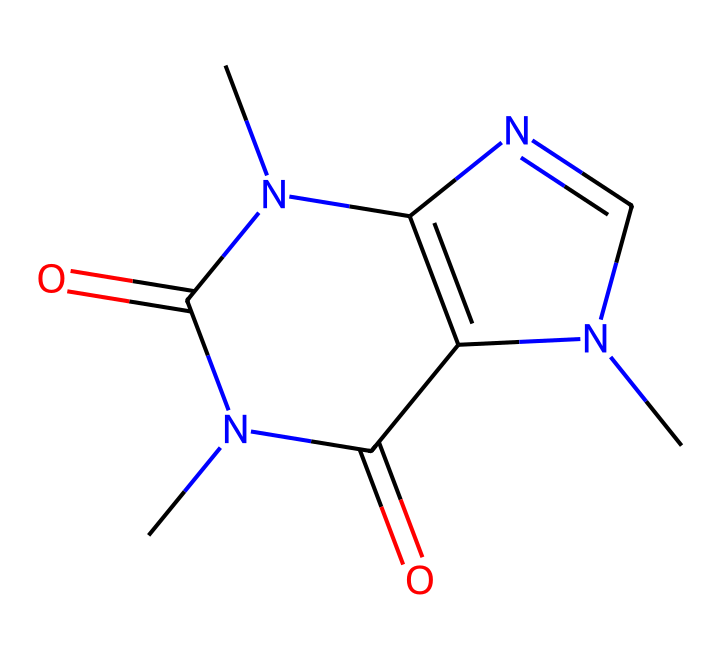What is the total number of nitrogen atoms in the caffeine structure? In the SMILES representation, "N" denotes nitrogen atoms. By examining the structure, we can count three nitrogen atoms present in the formula.
Answer: three How many carbon atoms are present in the caffeine structural formula? The SMILES representation includes "C" for carbon. Counting all the carbon atoms in the representation, we find eight carbon atoms present in the structure.
Answer: eight Which functional groups are indicated in the caffeine structure? The structure contains imine (C=N) and amide (C=O with attached N) functional groups. These are notable for caffeine's role in flavors and fragrances.
Answer: imine, amide What is the primary role of caffeine in energy gels? Caffeine serves as a stimulant, enhancing alertness and reducing fatigue, which is essential for athletic performance.
Answer: stimulant How does the presence of nitrogen influence the solubility of caffeine? The nitrogen atoms can form hydrogen bonds with water, increasing the solubility of caffeine compared to non-nitrogen-containing compounds.
Answer: increases What is the molecular weight of caffeine? The molecular weight can be calculated by summing the atomic weights of all the atoms in the SMILES representation, which totals approximately 194.19 g/mol.
Answer: 194.19 